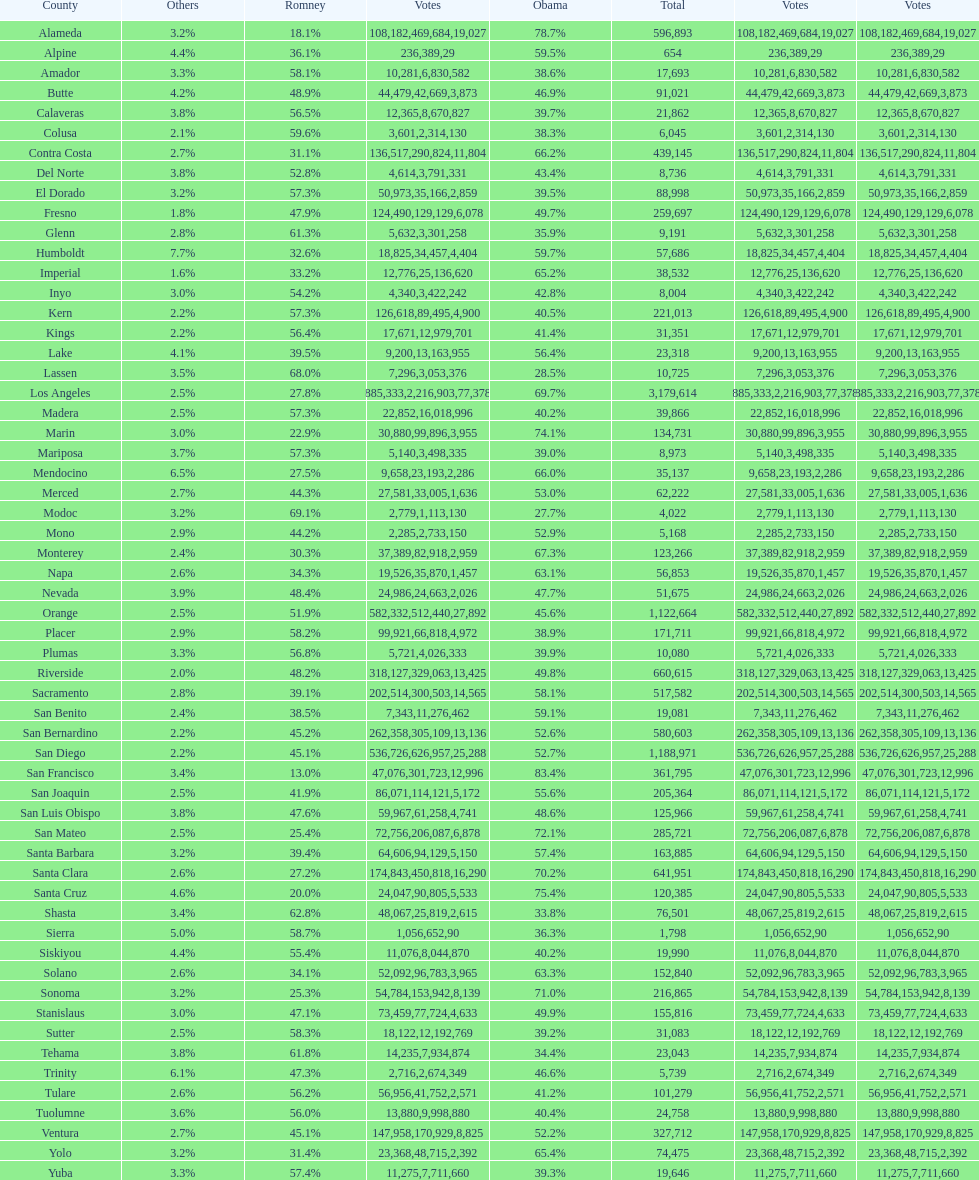Can you parse all the data within this table? {'header': ['County', 'Others', 'Romney', 'Votes', 'Obama', 'Total', 'Votes', 'Votes'], 'rows': [['Alameda', '3.2%', '18.1%', '108,182', '78.7%', '596,893', '469,684', '19,027'], ['Alpine', '4.4%', '36.1%', '236', '59.5%', '654', '389', '29'], ['Amador', '3.3%', '58.1%', '10,281', '38.6%', '17,693', '6,830', '582'], ['Butte', '4.2%', '48.9%', '44,479', '46.9%', '91,021', '42,669', '3,873'], ['Calaveras', '3.8%', '56.5%', '12,365', '39.7%', '21,862', '8,670', '827'], ['Colusa', '2.1%', '59.6%', '3,601', '38.3%', '6,045', '2,314', '130'], ['Contra Costa', '2.7%', '31.1%', '136,517', '66.2%', '439,145', '290,824', '11,804'], ['Del Norte', '3.8%', '52.8%', '4,614', '43.4%', '8,736', '3,791', '331'], ['El Dorado', '3.2%', '57.3%', '50,973', '39.5%', '88,998', '35,166', '2,859'], ['Fresno', '1.8%', '47.9%', '124,490', '49.7%', '259,697', '129,129', '6,078'], ['Glenn', '2.8%', '61.3%', '5,632', '35.9%', '9,191', '3,301', '258'], ['Humboldt', '7.7%', '32.6%', '18,825', '59.7%', '57,686', '34,457', '4,404'], ['Imperial', '1.6%', '33.2%', '12,776', '65.2%', '38,532', '25,136', '620'], ['Inyo', '3.0%', '54.2%', '4,340', '42.8%', '8,004', '3,422', '242'], ['Kern', '2.2%', '57.3%', '126,618', '40.5%', '221,013', '89,495', '4,900'], ['Kings', '2.2%', '56.4%', '17,671', '41.4%', '31,351', '12,979', '701'], ['Lake', '4.1%', '39.5%', '9,200', '56.4%', '23,318', '13,163', '955'], ['Lassen', '3.5%', '68.0%', '7,296', '28.5%', '10,725', '3,053', '376'], ['Los Angeles', '2.5%', '27.8%', '885,333', '69.7%', '3,179,614', '2,216,903', '77,378'], ['Madera', '2.5%', '57.3%', '22,852', '40.2%', '39,866', '16,018', '996'], ['Marin', '3.0%', '22.9%', '30,880', '74.1%', '134,731', '99,896', '3,955'], ['Mariposa', '3.7%', '57.3%', '5,140', '39.0%', '8,973', '3,498', '335'], ['Mendocino', '6.5%', '27.5%', '9,658', '66.0%', '35,137', '23,193', '2,286'], ['Merced', '2.7%', '44.3%', '27,581', '53.0%', '62,222', '33,005', '1,636'], ['Modoc', '3.2%', '69.1%', '2,779', '27.7%', '4,022', '1,113', '130'], ['Mono', '2.9%', '44.2%', '2,285', '52.9%', '5,168', '2,733', '150'], ['Monterey', '2.4%', '30.3%', '37,389', '67.3%', '123,266', '82,918', '2,959'], ['Napa', '2.6%', '34.3%', '19,526', '63.1%', '56,853', '35,870', '1,457'], ['Nevada', '3.9%', '48.4%', '24,986', '47.7%', '51,675', '24,663', '2,026'], ['Orange', '2.5%', '51.9%', '582,332', '45.6%', '1,122,664', '512,440', '27,892'], ['Placer', '2.9%', '58.2%', '99,921', '38.9%', '171,711', '66,818', '4,972'], ['Plumas', '3.3%', '56.8%', '5,721', '39.9%', '10,080', '4,026', '333'], ['Riverside', '2.0%', '48.2%', '318,127', '49.8%', '660,615', '329,063', '13,425'], ['Sacramento', '2.8%', '39.1%', '202,514', '58.1%', '517,582', '300,503', '14,565'], ['San Benito', '2.4%', '38.5%', '7,343', '59.1%', '19,081', '11,276', '462'], ['San Bernardino', '2.2%', '45.2%', '262,358', '52.6%', '580,603', '305,109', '13,136'], ['San Diego', '2.2%', '45.1%', '536,726', '52.7%', '1,188,971', '626,957', '25,288'], ['San Francisco', '3.4%', '13.0%', '47,076', '83.4%', '361,795', '301,723', '12,996'], ['San Joaquin', '2.5%', '41.9%', '86,071', '55.6%', '205,364', '114,121', '5,172'], ['San Luis Obispo', '3.8%', '47.6%', '59,967', '48.6%', '125,966', '61,258', '4,741'], ['San Mateo', '2.5%', '25.4%', '72,756', '72.1%', '285,721', '206,087', '6,878'], ['Santa Barbara', '3.2%', '39.4%', '64,606', '57.4%', '163,885', '94,129', '5,150'], ['Santa Clara', '2.6%', '27.2%', '174,843', '70.2%', '641,951', '450,818', '16,290'], ['Santa Cruz', '4.6%', '20.0%', '24,047', '75.4%', '120,385', '90,805', '5,533'], ['Shasta', '3.4%', '62.8%', '48,067', '33.8%', '76,501', '25,819', '2,615'], ['Sierra', '5.0%', '58.7%', '1,056', '36.3%', '1,798', '652', '90'], ['Siskiyou', '4.4%', '55.4%', '11,076', '40.2%', '19,990', '8,044', '870'], ['Solano', '2.6%', '34.1%', '52,092', '63.3%', '152,840', '96,783', '3,965'], ['Sonoma', '3.2%', '25.3%', '54,784', '71.0%', '216,865', '153,942', '8,139'], ['Stanislaus', '3.0%', '47.1%', '73,459', '49.9%', '155,816', '77,724', '4,633'], ['Sutter', '2.5%', '58.3%', '18,122', '39.2%', '31,083', '12,192', '769'], ['Tehama', '3.8%', '61.8%', '14,235', '34.4%', '23,043', '7,934', '874'], ['Trinity', '6.1%', '47.3%', '2,716', '46.6%', '5,739', '2,674', '349'], ['Tulare', '2.6%', '56.2%', '56,956', '41.2%', '101,279', '41,752', '2,571'], ['Tuolumne', '3.6%', '56.0%', '13,880', '40.4%', '24,758', '9,998', '880'], ['Ventura', '2.7%', '45.1%', '147,958', '52.2%', '327,712', '170,929', '8,825'], ['Yolo', '3.2%', '31.4%', '23,368', '65.4%', '74,475', '48,715', '2,392'], ['Yuba', '3.3%', '57.4%', '11,275', '39.3%', '19,646', '7,711', '660']]} What is the total number of votes for amador? 17693. 